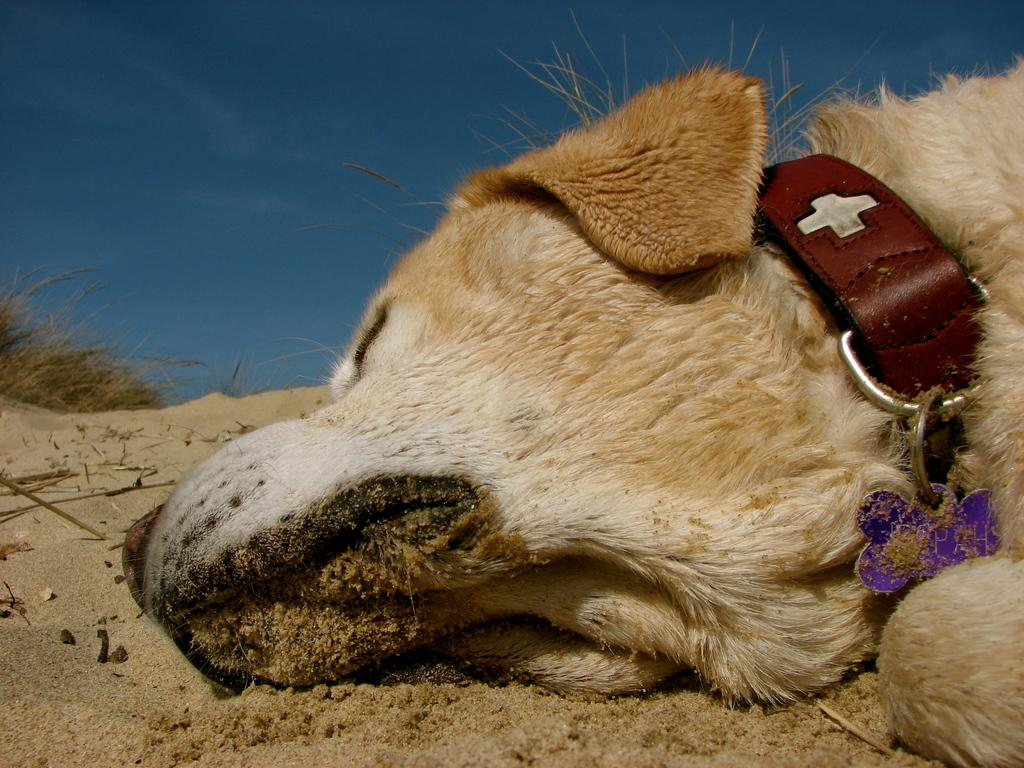What animal can be seen in the image? There is a dog in the image. What is the dog doing in the image? The dog is sleeping. Where is the dog located in the image? The dog is on the sand. What type of vegetation is visible in the background of the image? There is grass in the background of the image. What part of the natural environment is visible in the background of the image? The sky is visible in the background of the image. What type of glove is the dog wearing in the image? There is no glove present in the image, and the dog is not wearing any clothing or accessories. 